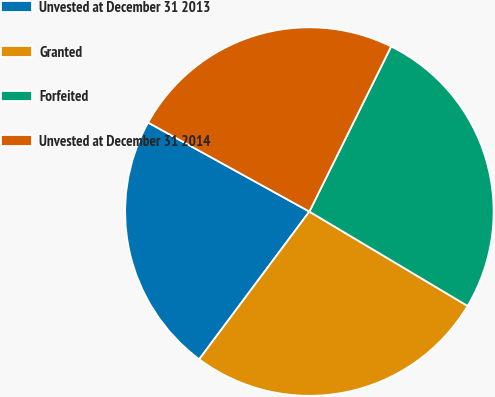Convert chart to OTSL. <chart><loc_0><loc_0><loc_500><loc_500><pie_chart><fcel>Unvested at December 31 2013<fcel>Granted<fcel>Forfeited<fcel>Unvested at December 31 2014<nl><fcel>22.83%<fcel>26.64%<fcel>26.24%<fcel>24.29%<nl></chart> 